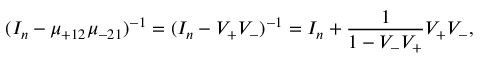Convert formula to latex. <formula><loc_0><loc_0><loc_500><loc_500>( I _ { n } - \mu _ { + 1 2 } \mu _ { - 2 1 } ) ^ { - 1 } = ( I _ { n } - V _ { + } V _ { - } ) ^ { - 1 } = I _ { n } + \frac { 1 } { 1 - V _ { - } V _ { + } } V _ { + } V _ { - } ,</formula> 